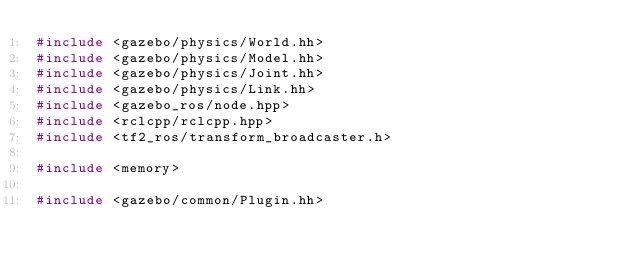Convert code to text. <code><loc_0><loc_0><loc_500><loc_500><_C++_>#include <gazebo/physics/World.hh>
#include <gazebo/physics/Model.hh>
#include <gazebo/physics/Joint.hh>
#include <gazebo/physics/Link.hh>
#include <gazebo_ros/node.hpp>
#include <rclcpp/rclcpp.hpp>
#include <tf2_ros/transform_broadcaster.h>

#include <memory>

#include <gazebo/common/Plugin.hh></code> 